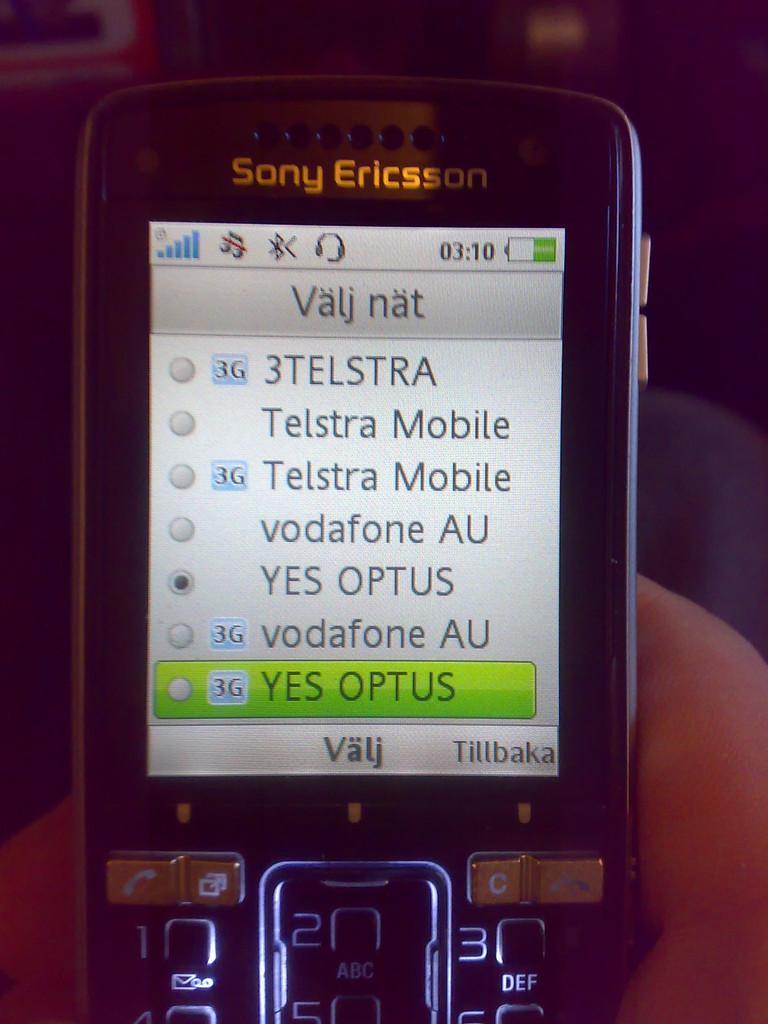<image>
Render a clear and concise summary of the photo. A Sony Ericsson phone has the word Valj at the bottom. 